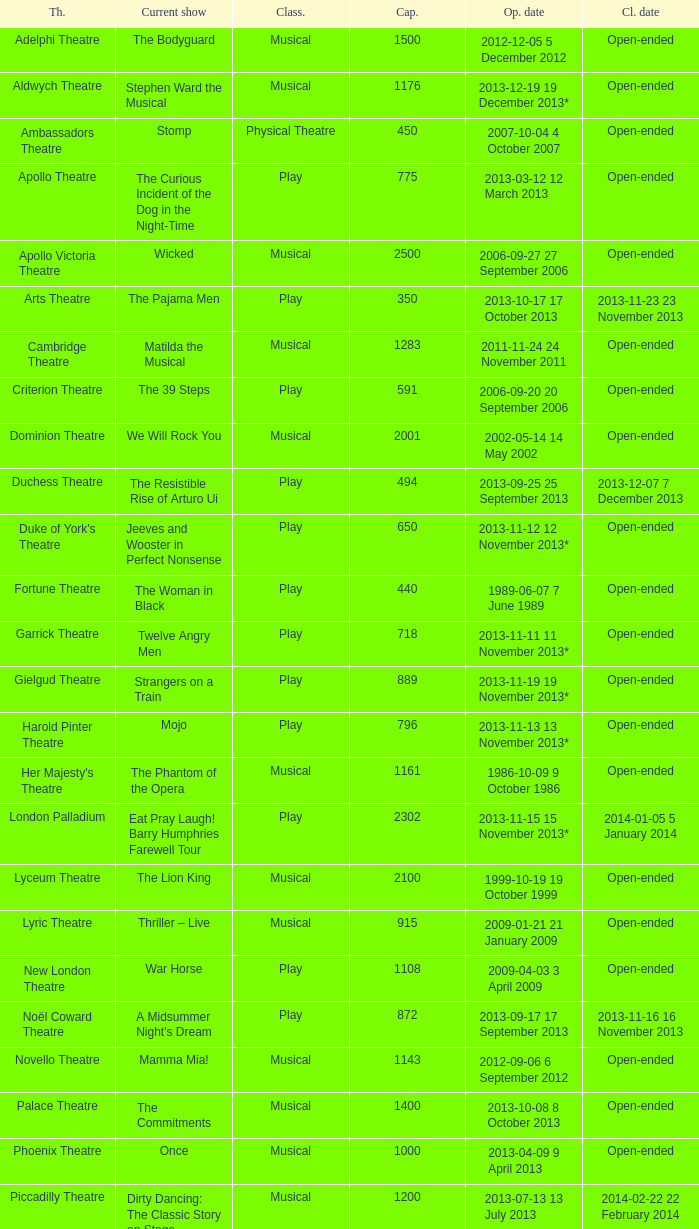What is the opening date of the musical at the adelphi theatre? 2012-12-05 5 December 2012. I'm looking to parse the entire table for insights. Could you assist me with that? {'header': ['Th.', 'Current show', 'Class.', 'Cap.', 'Op. date', 'Cl. date'], 'rows': [['Adelphi Theatre', 'The Bodyguard', 'Musical', '1500', '2012-12-05 5 December 2012', 'Open-ended'], ['Aldwych Theatre', 'Stephen Ward the Musical', 'Musical', '1176', '2013-12-19 19 December 2013*', 'Open-ended'], ['Ambassadors Theatre', 'Stomp', 'Physical Theatre', '450', '2007-10-04 4 October 2007', 'Open-ended'], ['Apollo Theatre', 'The Curious Incident of the Dog in the Night-Time', 'Play', '775', '2013-03-12 12 March 2013', 'Open-ended'], ['Apollo Victoria Theatre', 'Wicked', 'Musical', '2500', '2006-09-27 27 September 2006', 'Open-ended'], ['Arts Theatre', 'The Pajama Men', 'Play', '350', '2013-10-17 17 October 2013', '2013-11-23 23 November 2013'], ['Cambridge Theatre', 'Matilda the Musical', 'Musical', '1283', '2011-11-24 24 November 2011', 'Open-ended'], ['Criterion Theatre', 'The 39 Steps', 'Play', '591', '2006-09-20 20 September 2006', 'Open-ended'], ['Dominion Theatre', 'We Will Rock You', 'Musical', '2001', '2002-05-14 14 May 2002', 'Open-ended'], ['Duchess Theatre', 'The Resistible Rise of Arturo Ui', 'Play', '494', '2013-09-25 25 September 2013', '2013-12-07 7 December 2013'], ["Duke of York's Theatre", 'Jeeves and Wooster in Perfect Nonsense', 'Play', '650', '2013-11-12 12 November 2013*', 'Open-ended'], ['Fortune Theatre', 'The Woman in Black', 'Play', '440', '1989-06-07 7 June 1989', 'Open-ended'], ['Garrick Theatre', 'Twelve Angry Men', 'Play', '718', '2013-11-11 11 November 2013*', 'Open-ended'], ['Gielgud Theatre', 'Strangers on a Train', 'Play', '889', '2013-11-19 19 November 2013*', 'Open-ended'], ['Harold Pinter Theatre', 'Mojo', 'Play', '796', '2013-11-13 13 November 2013*', 'Open-ended'], ["Her Majesty's Theatre", 'The Phantom of the Opera', 'Musical', '1161', '1986-10-09 9 October 1986', 'Open-ended'], ['London Palladium', 'Eat Pray Laugh! Barry Humphries Farewell Tour', 'Play', '2302', '2013-11-15 15 November 2013*', '2014-01-05 5 January 2014'], ['Lyceum Theatre', 'The Lion King', 'Musical', '2100', '1999-10-19 19 October 1999', 'Open-ended'], ['Lyric Theatre', 'Thriller – Live', 'Musical', '915', '2009-01-21 21 January 2009', 'Open-ended'], ['New London Theatre', 'War Horse', 'Play', '1108', '2009-04-03 3 April 2009', 'Open-ended'], ['Noël Coward Theatre', "A Midsummer Night's Dream", 'Play', '872', '2013-09-17 17 September 2013', '2013-11-16 16 November 2013'], ['Novello Theatre', 'Mamma Mia!', 'Musical', '1143', '2012-09-06 6 September 2012', 'Open-ended'], ['Palace Theatre', 'The Commitments', 'Musical', '1400', '2013-10-08 8 October 2013', 'Open-ended'], ['Phoenix Theatre', 'Once', 'Musical', '1000', '2013-04-09 9 April 2013', 'Open-ended'], ['Piccadilly Theatre', 'Dirty Dancing: The Classic Story on Stage', 'Musical', '1200', '2013-07-13 13 July 2013', '2014-02-22 22 February 2014'], ['Playhouse Theatre', "Monty Python's Spamalot", 'Musical', '786', '2012-11-20 20 November 2012', 'Open-ended'], ['Prince Edward Theatre', 'Jersey Boys', 'Musical', '1618', '2008-03-18 18 March 2008', '2014-03-09 9 March 2014'], ['Prince of Wales Theatre', 'The Book of Mormon', 'Musical', '1160', '2013-03-21 21 March 2013', 'Open-ended'], ["Queen's Theatre", 'Les Misérables', 'Musical', '1099', '2004-04-12 12 April 2004', 'Open-ended'], ['Savoy Theatre', 'Let It Be', 'Musical', '1158', '2013-02-01 1 February 2013', 'Open-ended'], ['Shaftesbury Theatre', 'From Here to Eternity the Musical', 'Musical', '1400', '2013-10-23 23 October 2013', 'Open-ended'], ['St. James Theatre', 'Scenes from a Marriage', 'Play', '312', '2013-09-11 11 September 2013', '2013-11-9 9 November 2013'], ["St Martin's Theatre", 'The Mousetrap', 'Play', '550', '1974-03-25 25 March 1974', 'Open-ended'], ['Theatre Royal, Haymarket', 'One Man, Two Guvnors', 'Play', '888', '2012-03-02 2 March 2012', '2013-03-01 1 March 2014'], ['Theatre Royal, Drury Lane', 'Charlie and the Chocolate Factory the Musical', 'Musical', '2220', '2013-06-25 25 June 2013', 'Open-ended'], ['Trafalgar Studios 1', 'The Pride', 'Play', '380', '2013-08-13 13 August 2013', '2013-11-23 23 November 2013'], ['Trafalgar Studios 2', 'Mrs. Lowry and Son', 'Play', '100', '2013-11-01 1 November 2013', '2013-11-23 23 November 2013'], ['Vaudeville Theatre', 'The Ladykillers', 'Play', '681', '2013-07-09 9 July 2013', '2013-11-16 16 November 2013'], ['Victoria Palace Theatre', 'Billy Elliot the Musical', 'Musical', '1517', '2005-05-11 11 May 2005', 'Open-ended'], ["Wyndham's Theatre", 'Barking in Essex', 'Play', '750', '2013-09-16 16 September 2013', '2014-01-04 4 January 2014']]} 